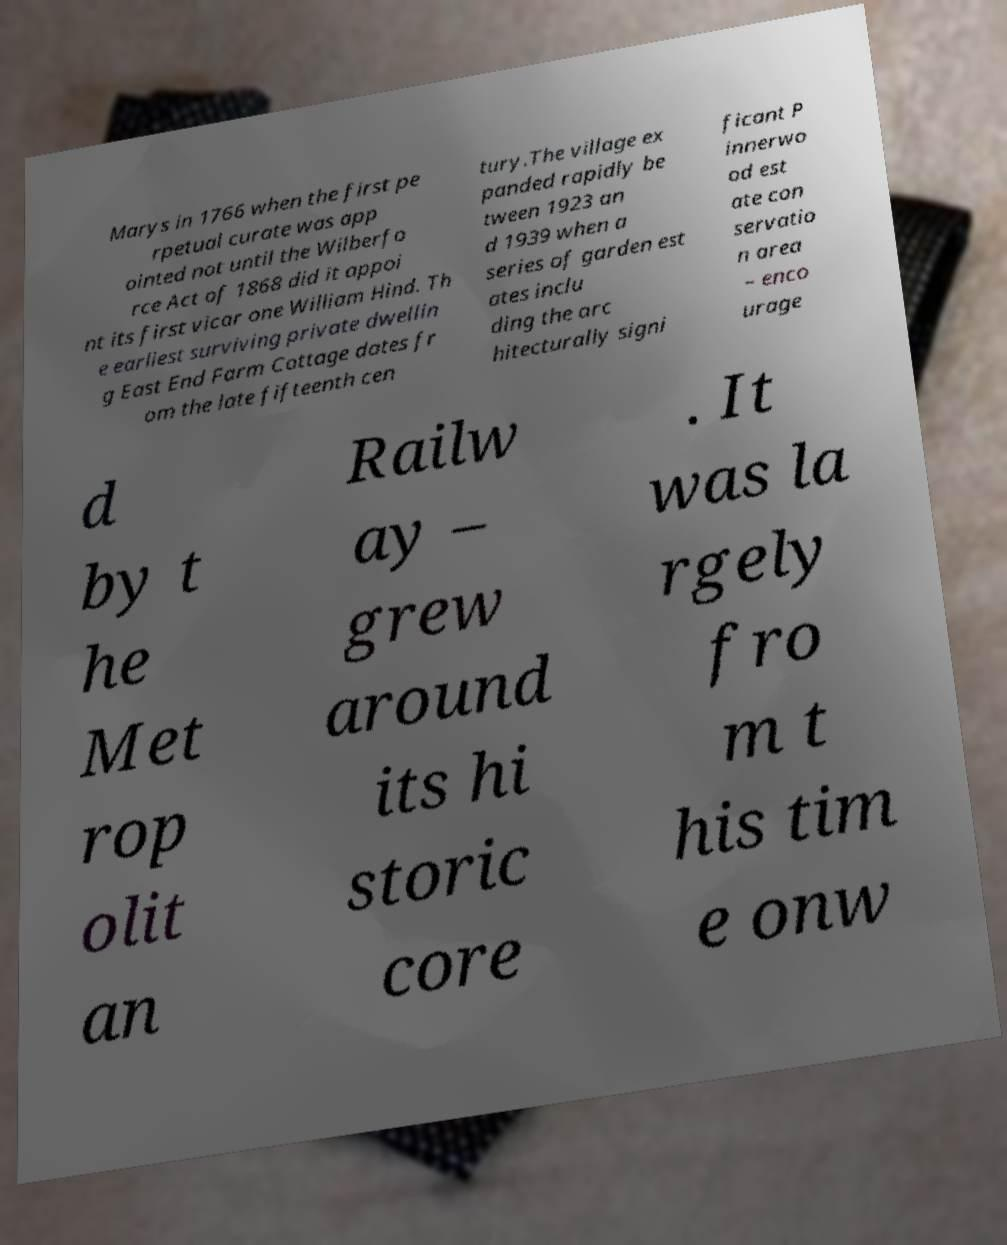Please identify and transcribe the text found in this image. Marys in 1766 when the first pe rpetual curate was app ointed not until the Wilberfo rce Act of 1868 did it appoi nt its first vicar one William Hind. Th e earliest surviving private dwellin g East End Farm Cottage dates fr om the late fifteenth cen tury.The village ex panded rapidly be tween 1923 an d 1939 when a series of garden est ates inclu ding the arc hitecturally signi ficant P innerwo od est ate con servatio n area – enco urage d by t he Met rop olit an Railw ay – grew around its hi storic core . It was la rgely fro m t his tim e onw 